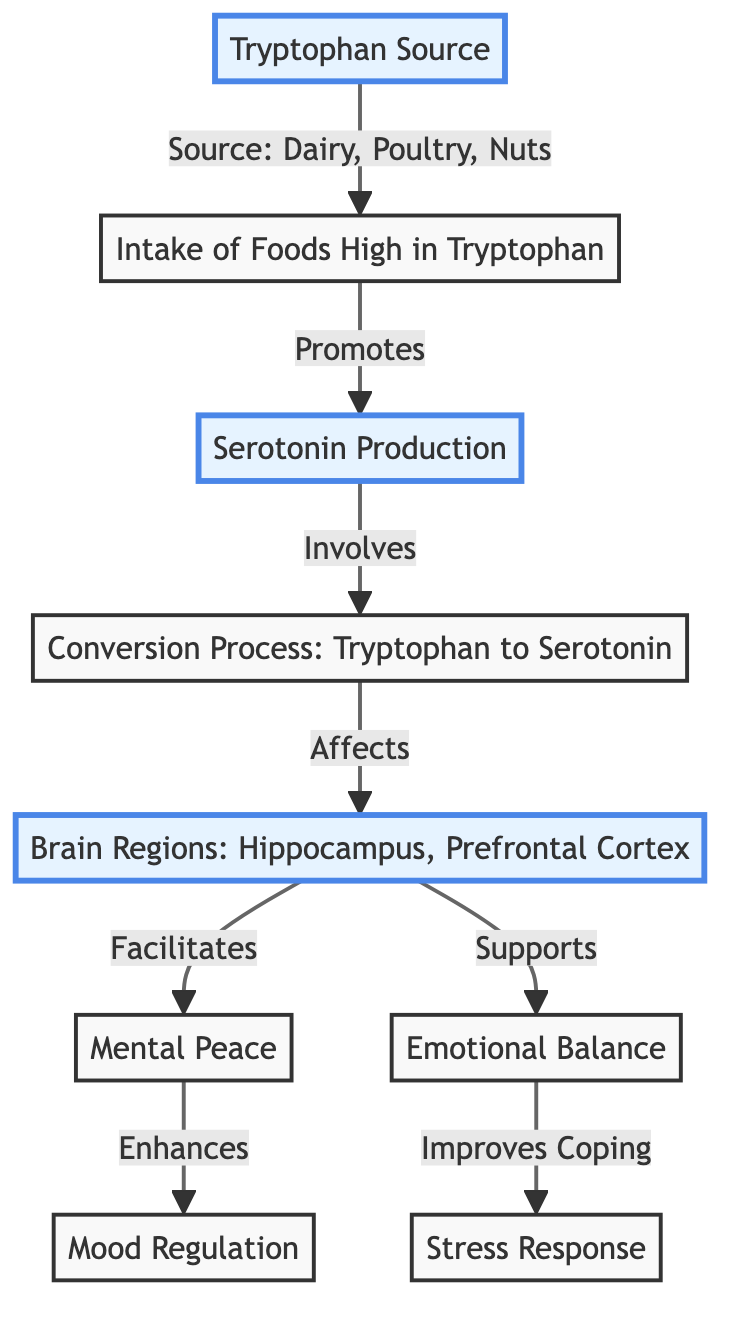What is the source of tryptophan? The diagram indicates that the source of tryptophan is dairy, poultry, and nuts, as shown directly from the node labeled "Tryptophan Source."
Answer: Dairy, Poultry, Nuts Which brain regions are impacted by serotonin production? According to the diagram, the brain regions affected by serotonin production are the hippocampus and prefrontal cortex, as stated in the "Brain Regions" node.
Answer: Hippocampus, Prefrontal Cortex How many nodes are there in total? By visually inspecting the diagram, there are a total of eight distinct nodes that represent different stages and concepts related to serotonin and its effects.
Answer: Eight What effects does serotonin facilitate in the brain? The diagram shows that serotonin facilitates mental peace and supports emotional balance, as detailed in the respective connections to the "Brain Regions."
Answer: Mental Peace, Emotional Balance Which food type promotes serotonin production? The diagram explicitly states that the intake of foods high in tryptophan promotes serotonin production, linking the nodes "Intake of Foods High in Tryptophan" and "Serotonin Production."
Answer: Foods high in tryptophan How does mental peace enhance mood regulation? From the diagram, it can be seen that mental peace enhances mood regulation as it is directly linked in the flow of information from mental peace to mood regulation.
Answer: Enhances What is the relationship between emotional balance and stress response? The diagram illustrates that emotional balance improves coping with stress response, indicating a supportive relationship between the two concepts.
Answer: Improves Coping Are both the hippocampus and prefrontal cortex directly involved in emotional balance? The flow indicates that both brain regions are influenced by serotonin production, and while they facilitate mental peace, the diagram does not specifically link them exclusively to emotional balance.
Answer: No How does serotonin production relate to coping with stress response? The diagram shows that serotonin production indirectly impacts stress response through its influence on emotional balance, making this a multi-step relationship.
Answer: Indirectly What is the major function of serotonin indicated in the diagram? The major functions of serotonin indicated in the diagram include maintaining mental peace and emotional balance, synthesized through its production process.
Answer: Mental Peace, Emotional Balance 